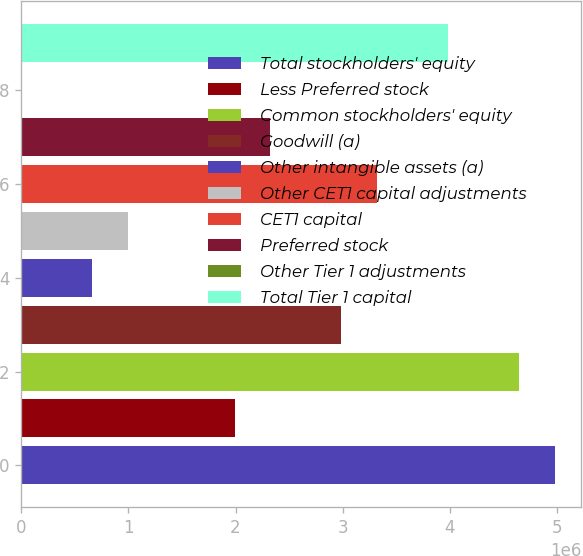Convert chart to OTSL. <chart><loc_0><loc_0><loc_500><loc_500><bar_chart><fcel>Total stockholders' equity<fcel>Less Preferred stock<fcel>Common stockholders' equity<fcel>Goodwill (a)<fcel>Other intangible assets (a)<fcel>Other CET1 capital adjustments<fcel>CET1 capital<fcel>Preferred stock<fcel>Other Tier 1 adjustments<fcel>Total Tier 1 capital<nl><fcel>4.9806e+06<fcel>1.99224e+06<fcel>4.64856e+06<fcel>2.98836e+06<fcel>664085<fcel>996125<fcel>3.3204e+06<fcel>2.32428e+06<fcel>5<fcel>3.98448e+06<nl></chart> 